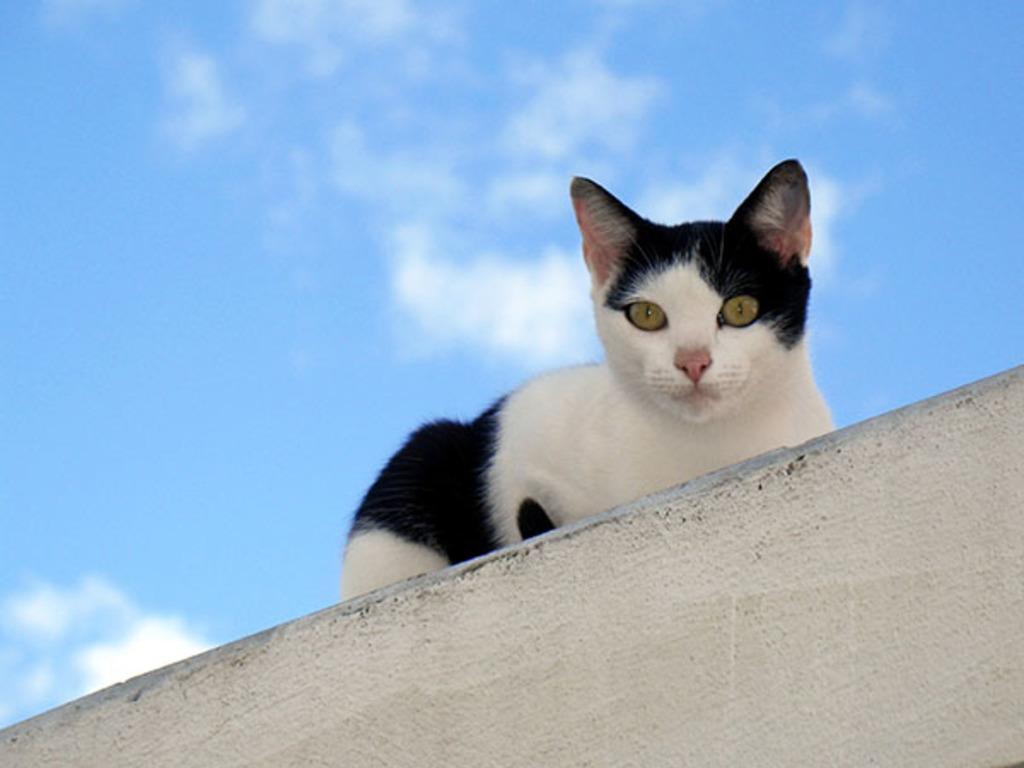In one or two sentences, can you explain what this image depicts? In this image there is a cat on the wall. In the background there is a sky with some clouds. 